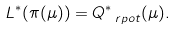Convert formula to latex. <formula><loc_0><loc_0><loc_500><loc_500>L ^ { * } ( \pi ( \mu ) ) = Q _ { \ r p o t } ^ { * } ( \mu ) .</formula> 